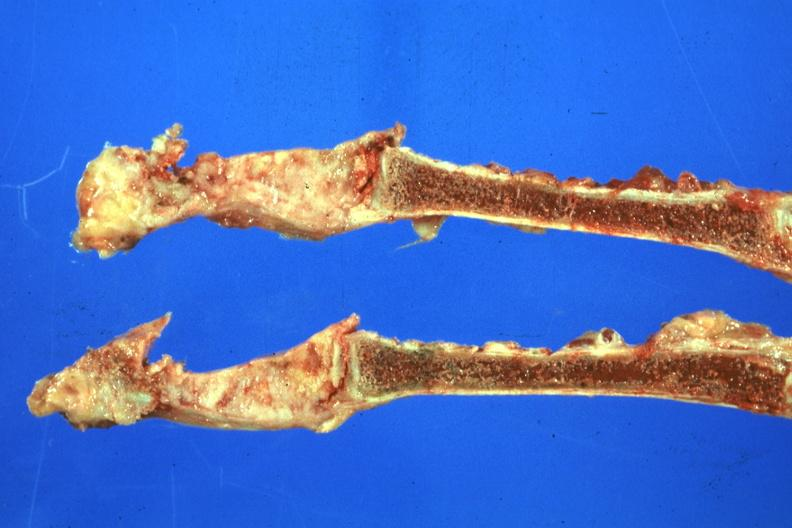does this image show saggital section sternum obvious lesion scar carcinoma?
Answer the question using a single word or phrase. Yes 